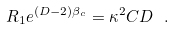Convert formula to latex. <formula><loc_0><loc_0><loc_500><loc_500>R _ { 1 } e ^ { ( D - 2 ) \beta _ { c } } = \kappa ^ { 2 } C D \ .</formula> 